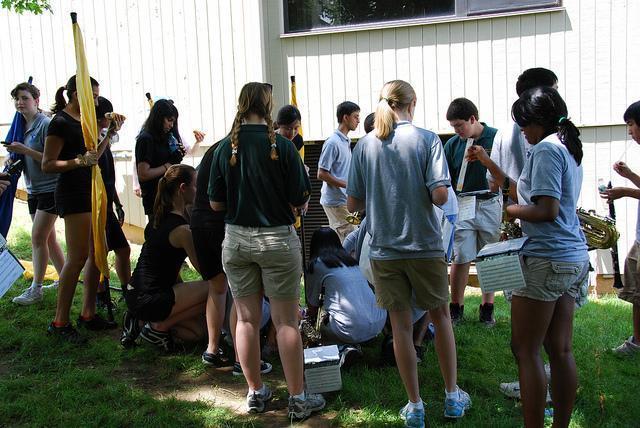How many out of fifteen people are male?
Give a very brief answer. 3. How many people are in the photo?
Give a very brief answer. 13. How many scissors are child sized?
Give a very brief answer. 0. 